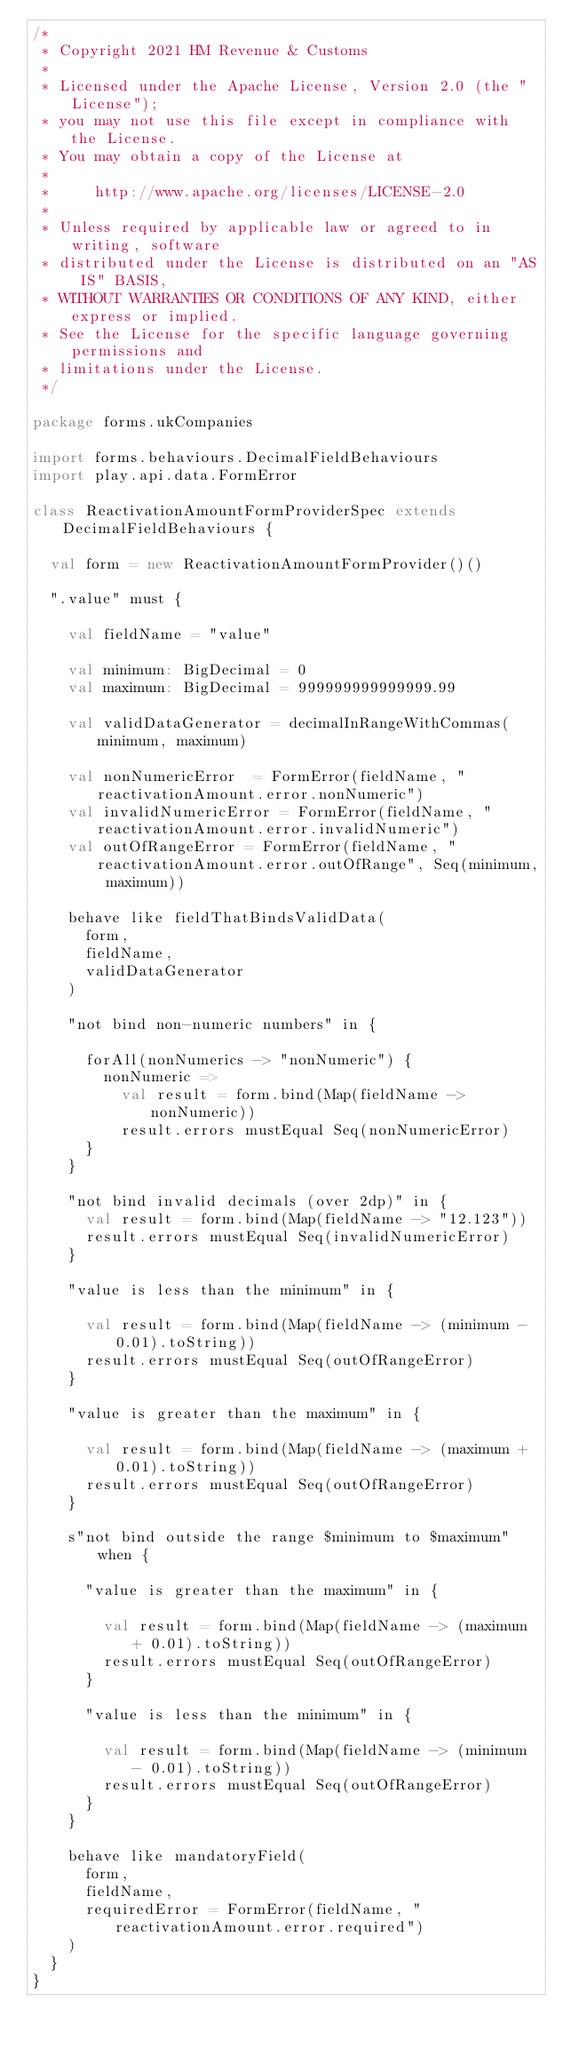<code> <loc_0><loc_0><loc_500><loc_500><_Scala_>/*
 * Copyright 2021 HM Revenue & Customs
 *
 * Licensed under the Apache License, Version 2.0 (the "License");
 * you may not use this file except in compliance with the License.
 * You may obtain a copy of the License at
 *
 *     http://www.apache.org/licenses/LICENSE-2.0
 *
 * Unless required by applicable law or agreed to in writing, software
 * distributed under the License is distributed on an "AS IS" BASIS,
 * WITHOUT WARRANTIES OR CONDITIONS OF ANY KIND, either express or implied.
 * See the License for the specific language governing permissions and
 * limitations under the License.
 */

package forms.ukCompanies

import forms.behaviours.DecimalFieldBehaviours
import play.api.data.FormError

class ReactivationAmountFormProviderSpec extends DecimalFieldBehaviours {

  val form = new ReactivationAmountFormProvider()()

  ".value" must {

    val fieldName = "value"

    val minimum: BigDecimal = 0
    val maximum: BigDecimal = 999999999999999.99

    val validDataGenerator = decimalInRangeWithCommas(minimum, maximum)

    val nonNumericError  = FormError(fieldName, "reactivationAmount.error.nonNumeric")
    val invalidNumericError = FormError(fieldName, "reactivationAmount.error.invalidNumeric")
    val outOfRangeError = FormError(fieldName, "reactivationAmount.error.outOfRange", Seq(minimum, maximum))

    behave like fieldThatBindsValidData(
      form,
      fieldName,
      validDataGenerator
    )

    "not bind non-numeric numbers" in {

      forAll(nonNumerics -> "nonNumeric") {
        nonNumeric =>
          val result = form.bind(Map(fieldName -> nonNumeric))
          result.errors mustEqual Seq(nonNumericError)
      }
    }

    "not bind invalid decimals (over 2dp)" in {
      val result = form.bind(Map(fieldName -> "12.123"))
      result.errors mustEqual Seq(invalidNumericError)
    }

    "value is less than the minimum" in {

      val result = form.bind(Map(fieldName -> (minimum - 0.01).toString))
      result.errors mustEqual Seq(outOfRangeError)
    }

    "value is greater than the maximum" in {

      val result = form.bind(Map(fieldName -> (maximum + 0.01).toString))
      result.errors mustEqual Seq(outOfRangeError)
    }

    s"not bind outside the range $minimum to $maximum" when {

      "value is greater than the maximum" in {

        val result = form.bind(Map(fieldName -> (maximum + 0.01).toString))
        result.errors mustEqual Seq(outOfRangeError)
      }

      "value is less than the minimum" in {

        val result = form.bind(Map(fieldName -> (minimum - 0.01).toString))
        result.errors mustEqual Seq(outOfRangeError)
      }
    }

    behave like mandatoryField(
      form,
      fieldName,
      requiredError = FormError(fieldName, "reactivationAmount.error.required")
    )
  }
}
</code> 